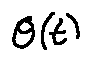<formula> <loc_0><loc_0><loc_500><loc_500>\theta ( t )</formula> 